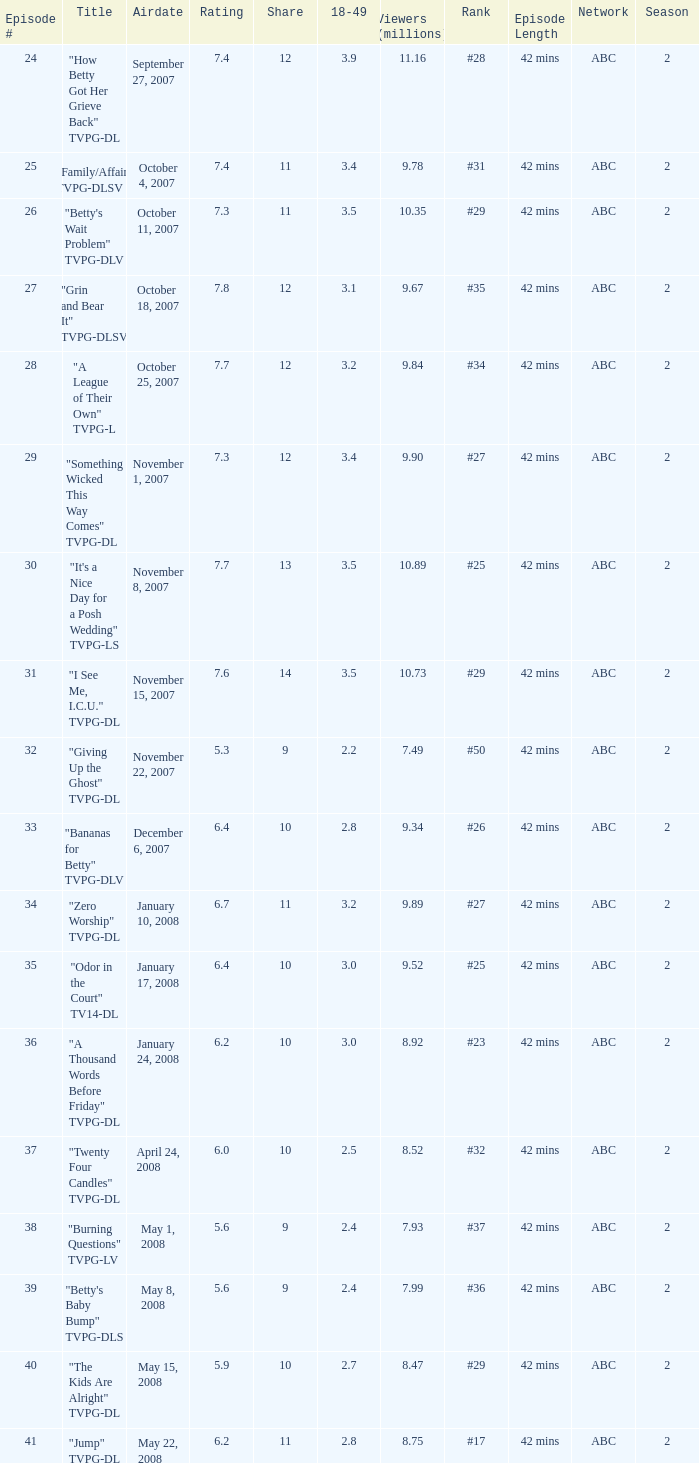What is the Airdate of the episode that ranked #29 and had a share greater than 10? May 15, 2008. 